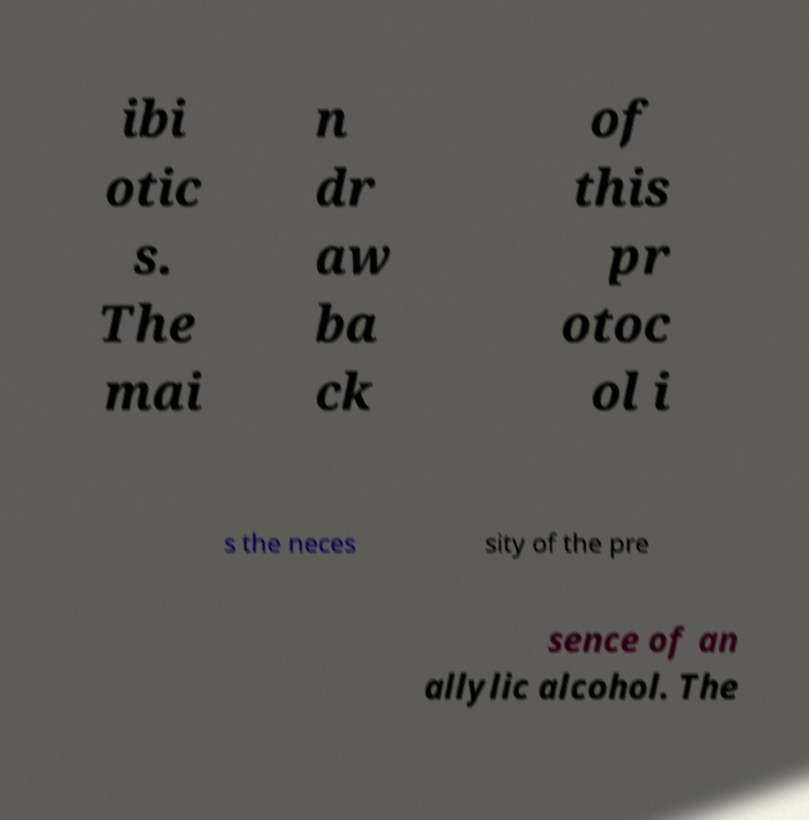I need the written content from this picture converted into text. Can you do that? ibi otic s. The mai n dr aw ba ck of this pr otoc ol i s the neces sity of the pre sence of an allylic alcohol. The 